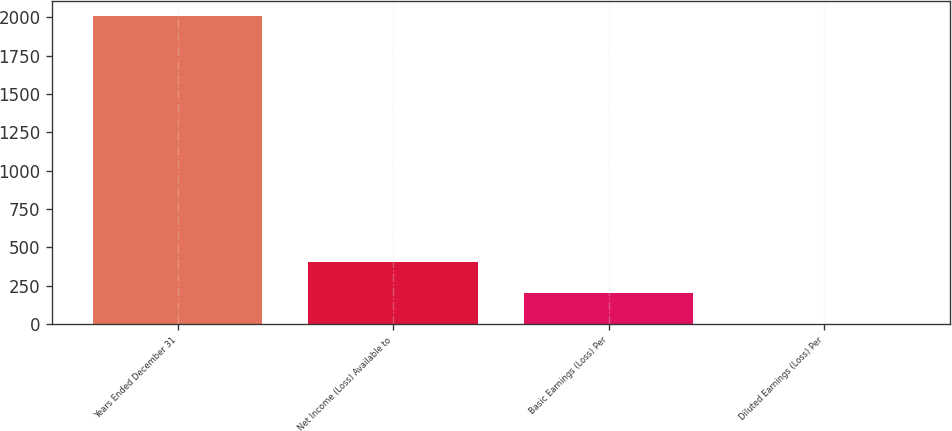Convert chart to OTSL. <chart><loc_0><loc_0><loc_500><loc_500><bar_chart><fcel>Years Ended December 31<fcel>Net Income (Loss) Available to<fcel>Basic Earnings (Loss) Per<fcel>Diluted Earnings (Loss) Per<nl><fcel>2009<fcel>402.53<fcel>201.72<fcel>0.91<nl></chart> 